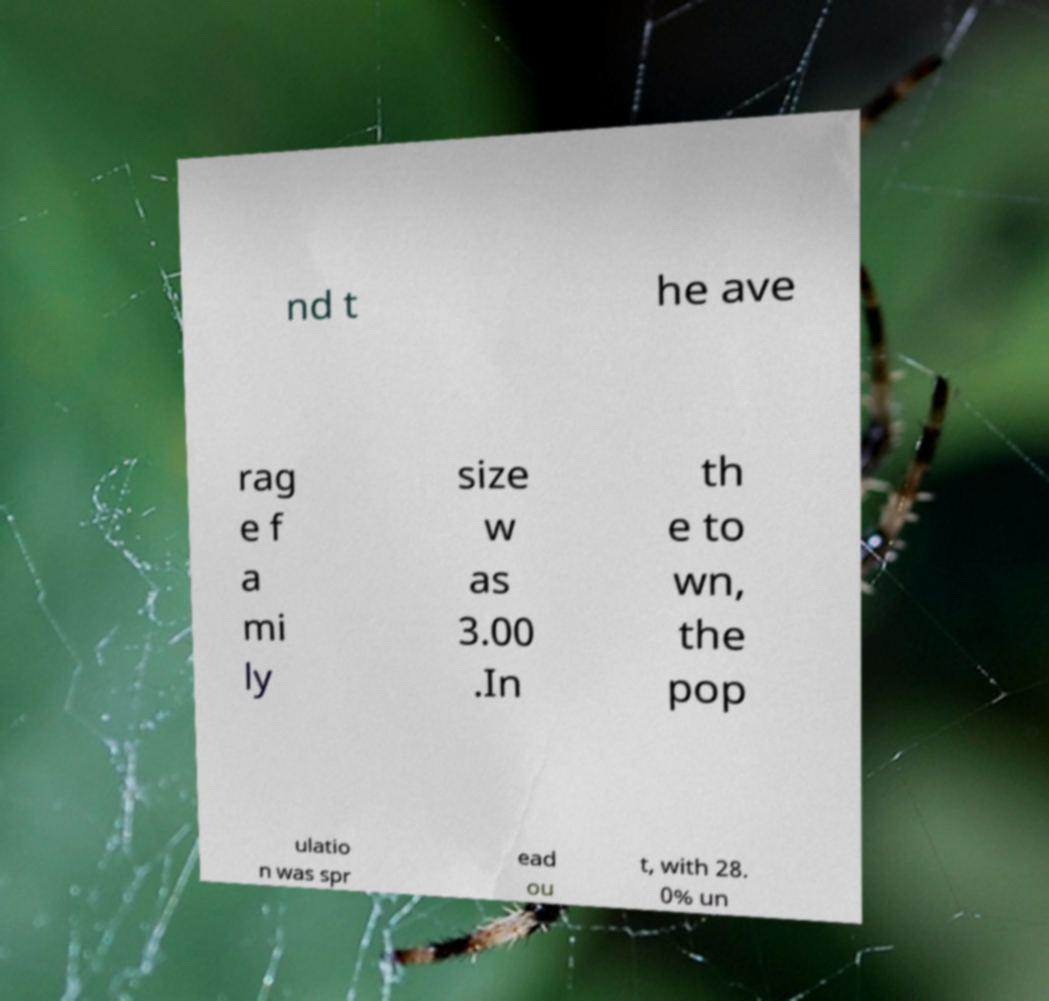Could you extract and type out the text from this image? nd t he ave rag e f a mi ly size w as 3.00 .In th e to wn, the pop ulatio n was spr ead ou t, with 28. 0% un 